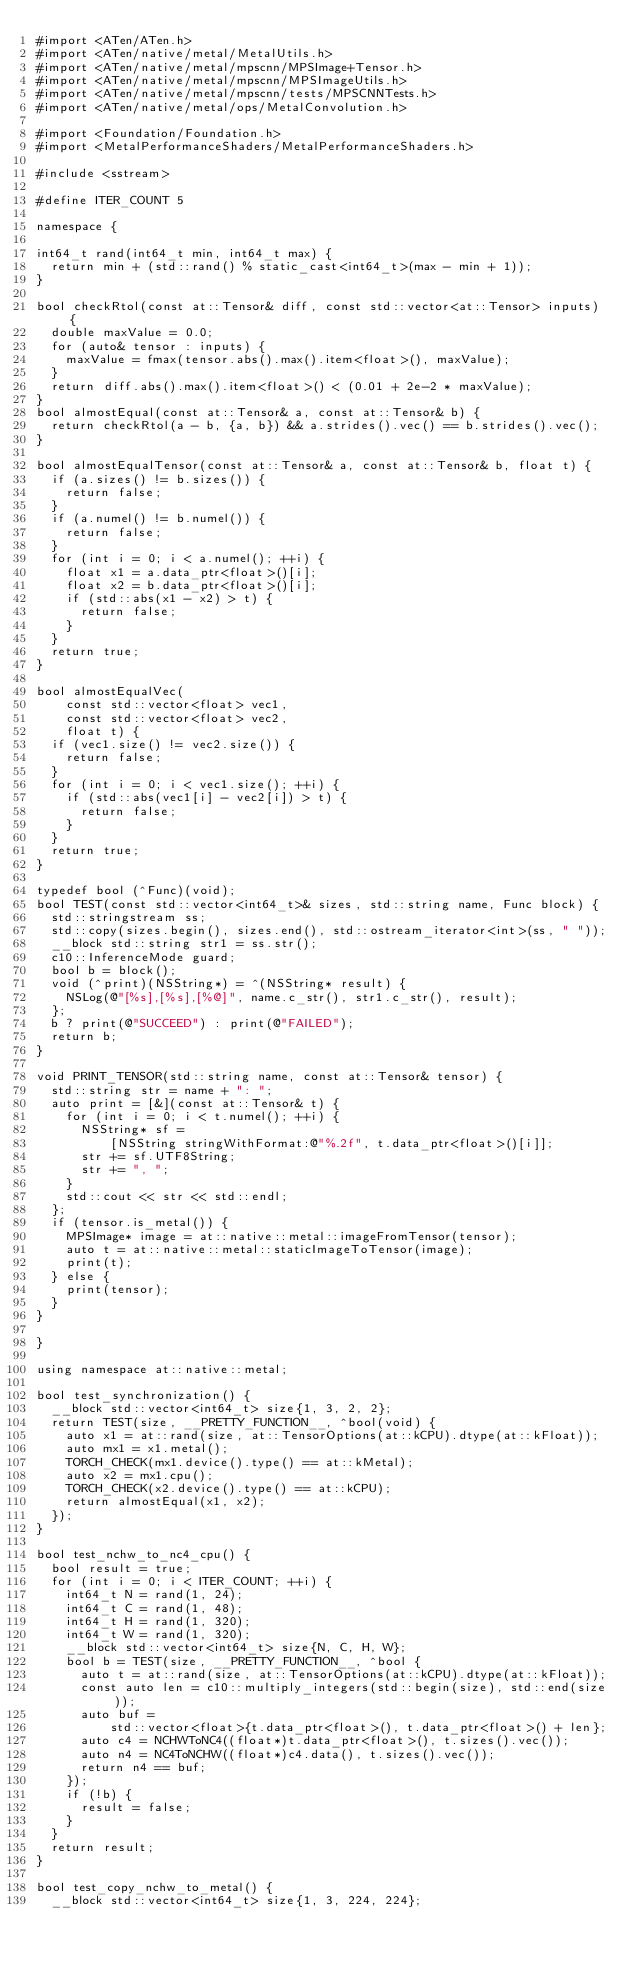<code> <loc_0><loc_0><loc_500><loc_500><_ObjectiveC_>#import <ATen/ATen.h>
#import <ATen/native/metal/MetalUtils.h>
#import <ATen/native/metal/mpscnn/MPSImage+Tensor.h>
#import <ATen/native/metal/mpscnn/MPSImageUtils.h>
#import <ATen/native/metal/mpscnn/tests/MPSCNNTests.h>
#import <ATen/native/metal/ops/MetalConvolution.h>

#import <Foundation/Foundation.h>
#import <MetalPerformanceShaders/MetalPerformanceShaders.h>

#include <sstream>

#define ITER_COUNT 5

namespace {

int64_t rand(int64_t min, int64_t max) {
  return min + (std::rand() % static_cast<int64_t>(max - min + 1));
}

bool checkRtol(const at::Tensor& diff, const std::vector<at::Tensor> inputs) {
  double maxValue = 0.0;
  for (auto& tensor : inputs) {
    maxValue = fmax(tensor.abs().max().item<float>(), maxValue);
  }
  return diff.abs().max().item<float>() < (0.01 + 2e-2 * maxValue);
}
bool almostEqual(const at::Tensor& a, const at::Tensor& b) {
  return checkRtol(a - b, {a, b}) && a.strides().vec() == b.strides().vec();
}

bool almostEqualTensor(const at::Tensor& a, const at::Tensor& b, float t) {
  if (a.sizes() != b.sizes()) {
    return false;
  }
  if (a.numel() != b.numel()) {
    return false;
  }
  for (int i = 0; i < a.numel(); ++i) {
    float x1 = a.data_ptr<float>()[i];
    float x2 = b.data_ptr<float>()[i];
    if (std::abs(x1 - x2) > t) {
      return false;
    }
  }
  return true;
}

bool almostEqualVec(
    const std::vector<float> vec1,
    const std::vector<float> vec2,
    float t) {
  if (vec1.size() != vec2.size()) {
    return false;
  }
  for (int i = 0; i < vec1.size(); ++i) {
    if (std::abs(vec1[i] - vec2[i]) > t) {
      return false;
    }
  }
  return true;
}

typedef bool (^Func)(void);
bool TEST(const std::vector<int64_t>& sizes, std::string name, Func block) {
  std::stringstream ss;
  std::copy(sizes.begin(), sizes.end(), std::ostream_iterator<int>(ss, " "));
  __block std::string str1 = ss.str();
  c10::InferenceMode guard;
  bool b = block();
  void (^print)(NSString*) = ^(NSString* result) {
    NSLog(@"[%s],[%s],[%@]", name.c_str(), str1.c_str(), result);
  };
  b ? print(@"SUCCEED") : print(@"FAILED");
  return b;
}

void PRINT_TENSOR(std::string name, const at::Tensor& tensor) {
  std::string str = name + ": ";
  auto print = [&](const at::Tensor& t) {
    for (int i = 0; i < t.numel(); ++i) {
      NSString* sf =
          [NSString stringWithFormat:@"%.2f", t.data_ptr<float>()[i]];
      str += sf.UTF8String;
      str += ", ";
    }
    std::cout << str << std::endl;
  };
  if (tensor.is_metal()) {
    MPSImage* image = at::native::metal::imageFromTensor(tensor);
    auto t = at::native::metal::staticImageToTensor(image);
    print(t);
  } else {
    print(tensor);
  }
}

}

using namespace at::native::metal;

bool test_synchronization() {
  __block std::vector<int64_t> size{1, 3, 2, 2};
  return TEST(size, __PRETTY_FUNCTION__, ^bool(void) {
    auto x1 = at::rand(size, at::TensorOptions(at::kCPU).dtype(at::kFloat));
    auto mx1 = x1.metal();
    TORCH_CHECK(mx1.device().type() == at::kMetal);
    auto x2 = mx1.cpu();
    TORCH_CHECK(x2.device().type() == at::kCPU);
    return almostEqual(x1, x2);
  });
}

bool test_nchw_to_nc4_cpu() {
  bool result = true;
  for (int i = 0; i < ITER_COUNT; ++i) {
    int64_t N = rand(1, 24);
    int64_t C = rand(1, 48);
    int64_t H = rand(1, 320);
    int64_t W = rand(1, 320);
    __block std::vector<int64_t> size{N, C, H, W};
    bool b = TEST(size, __PRETTY_FUNCTION__, ^bool {
      auto t = at::rand(size, at::TensorOptions(at::kCPU).dtype(at::kFloat));
      const auto len = c10::multiply_integers(std::begin(size), std::end(size));
      auto buf =
          std::vector<float>{t.data_ptr<float>(), t.data_ptr<float>() + len};
      auto c4 = NCHWToNC4((float*)t.data_ptr<float>(), t.sizes().vec());
      auto n4 = NC4ToNCHW((float*)c4.data(), t.sizes().vec());
      return n4 == buf;
    });
    if (!b) {
      result = false;
    }
  }
  return result;
}

bool test_copy_nchw_to_metal() {
  __block std::vector<int64_t> size{1, 3, 224, 224};</code> 